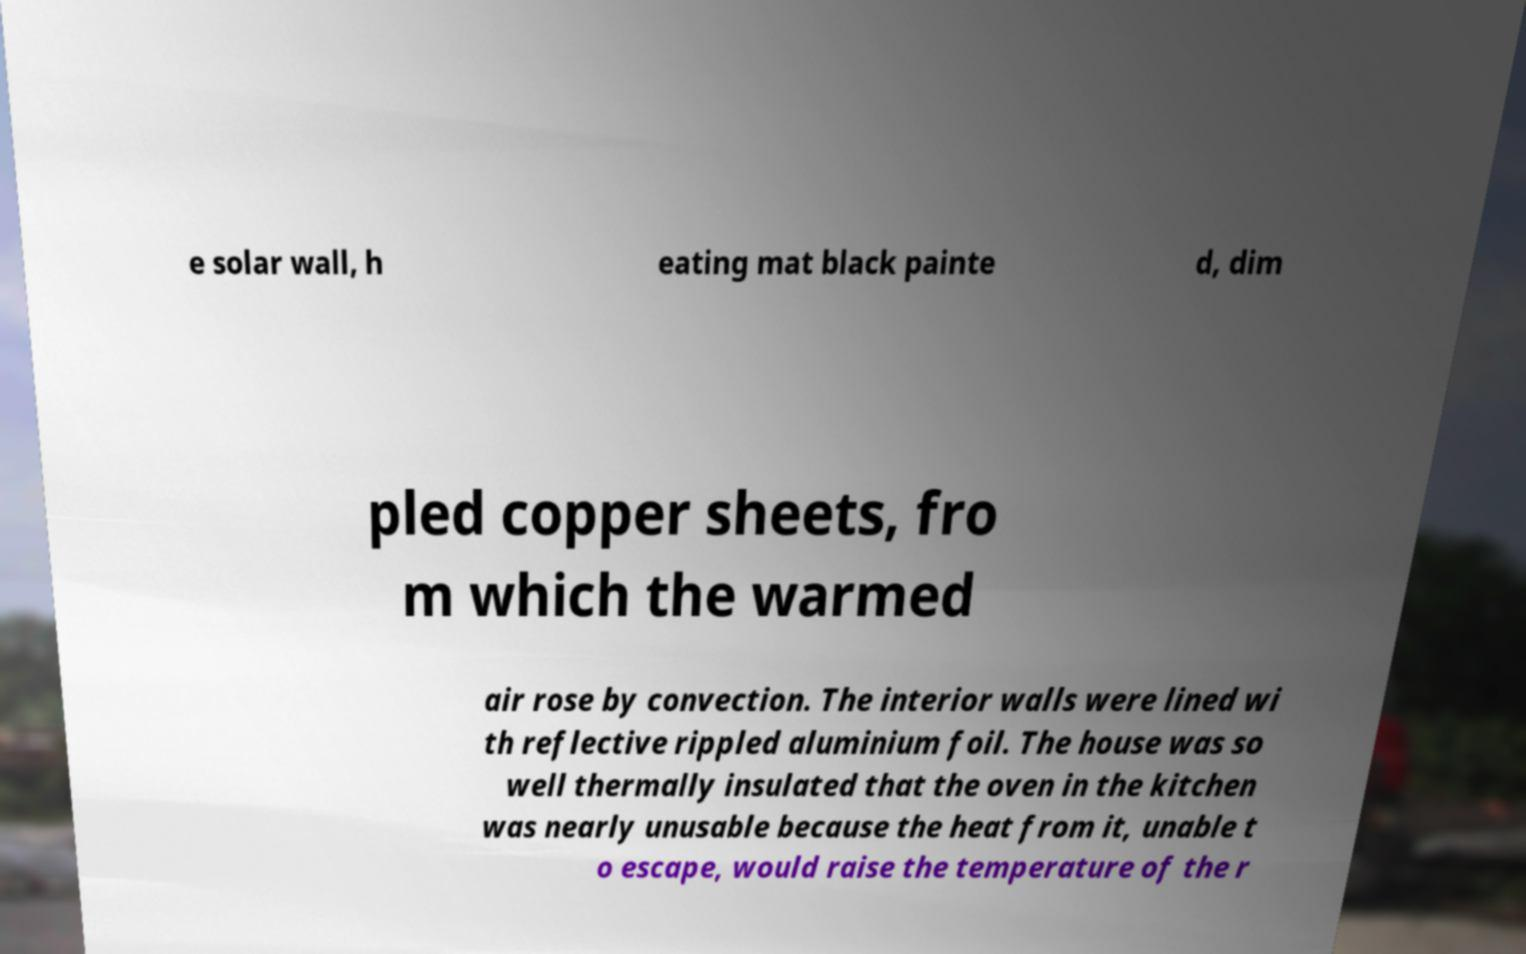Please identify and transcribe the text found in this image. e solar wall, h eating mat black painte d, dim pled copper sheets, fro m which the warmed air rose by convection. The interior walls were lined wi th reflective rippled aluminium foil. The house was so well thermally insulated that the oven in the kitchen was nearly unusable because the heat from it, unable t o escape, would raise the temperature of the r 